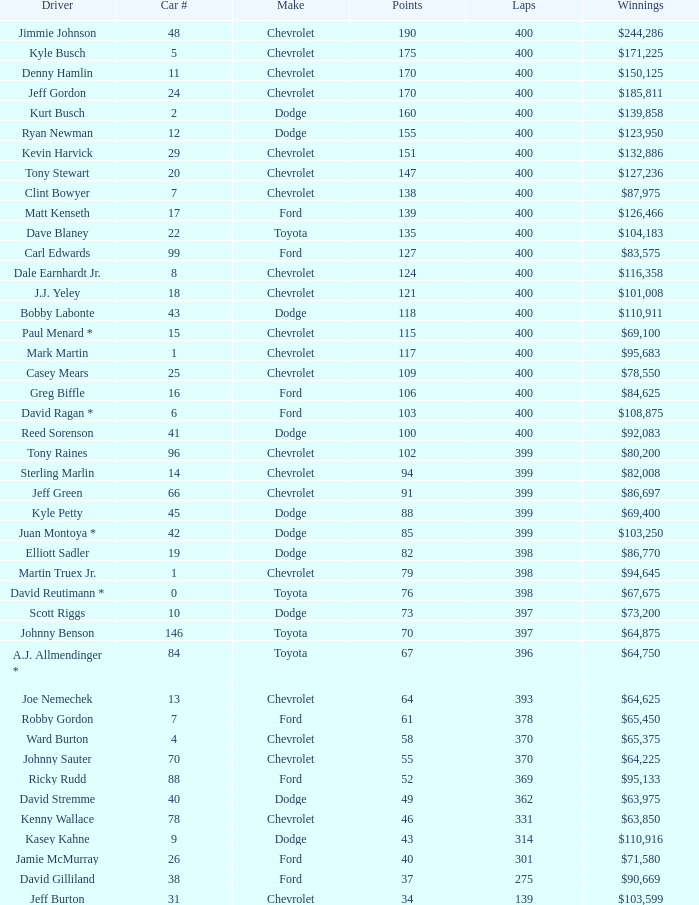What were the winnings for the Chevrolet with a number larger than 29 and scored 102 points? $80,200. 